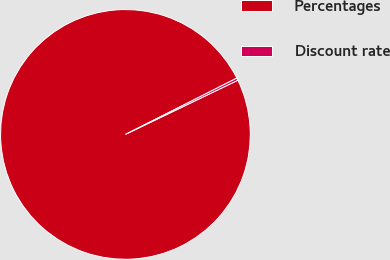<chart> <loc_0><loc_0><loc_500><loc_500><pie_chart><fcel>Percentages<fcel>Discount rate<nl><fcel>99.7%<fcel>0.3%<nl></chart> 